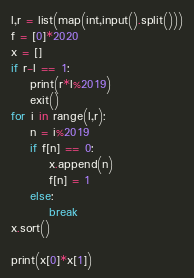<code> <loc_0><loc_0><loc_500><loc_500><_Python_>l,r = list(map(int,input().split()))
f = [0]*2020
x = []
if r-l == 1:
    print(r*l%2019)
    exit()
for i in range(l,r):
    n = i%2019
    if f[n] == 0:
        x.append(n)
        f[n] = 1
    else:
        break
x.sort()

print(x[0]*x[1])</code> 